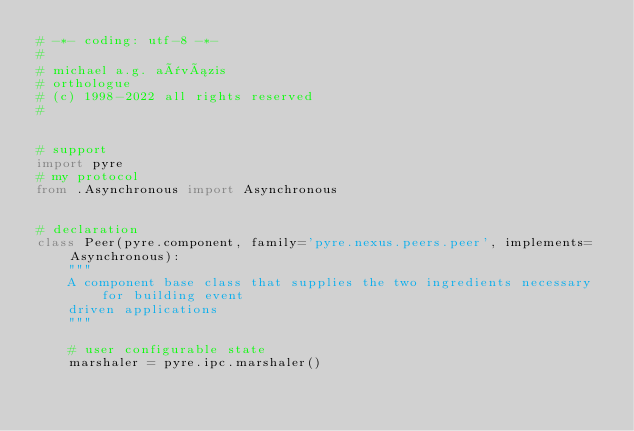<code> <loc_0><loc_0><loc_500><loc_500><_Python_># -*- coding: utf-8 -*-
#
# michael a.g. aïvázis
# orthologue
# (c) 1998-2022 all rights reserved
#


# support
import pyre
# my protocol
from .Asynchronous import Asynchronous


# declaration
class Peer(pyre.component, family='pyre.nexus.peers.peer', implements=Asynchronous):
    """
    A component base class that supplies the two ingredients necessary for building event
    driven applications
    """

    # user configurable state
    marshaler = pyre.ipc.marshaler()</code> 